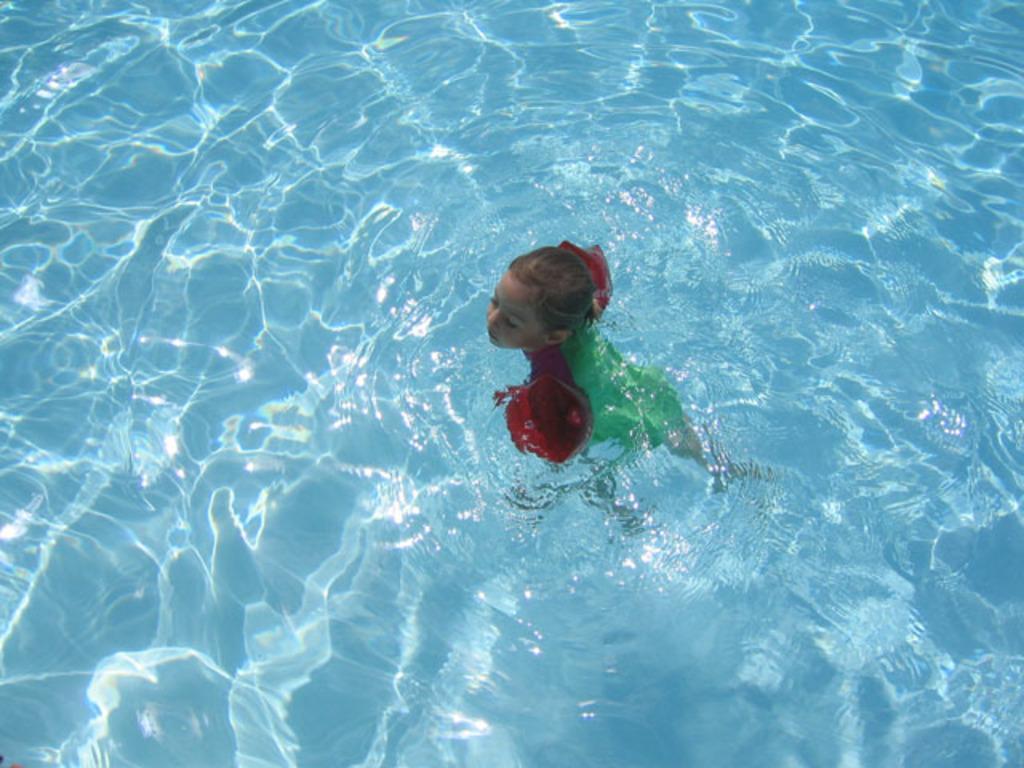How would you summarize this image in a sentence or two? In this image there is a girl swimming in the pool. 